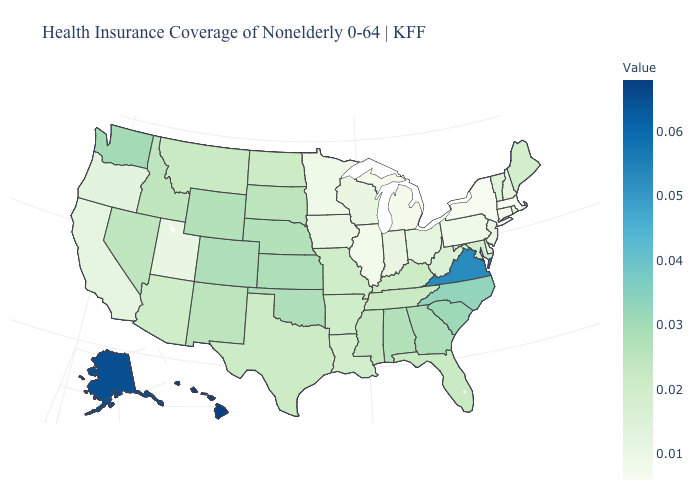Among the states that border Idaho , which have the lowest value?
Keep it brief. Utah. Among the states that border Ohio , does Kentucky have the lowest value?
Be succinct. No. Among the states that border Utah , which have the highest value?
Short answer required. Colorado. Which states have the highest value in the USA?
Be succinct. Hawaii. Among the states that border Georgia , does Tennessee have the lowest value?
Quick response, please. Yes. Among the states that border New Jersey , which have the highest value?
Quick response, please. Delaware. 